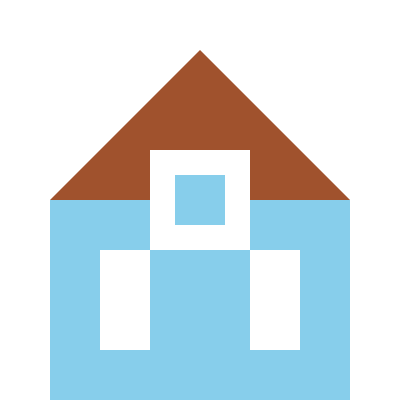Which famous Ontario landmark is represented by this abstract geometric composition? To identify the landmark, let's analyze the geometric shapes:

1. The overall structure is triangular, with a large triangle forming the main body.
2. There's a square shape in the center of the triangle, resembling a window or observation deck.
3. Two rectangular shapes at the bottom could represent legs or support structures.
4. The blue background suggests a sky, while the brown triangle implies a building.

These elements combined point to a iconic tower-like structure. In Ontario, the most famous landmark fitting this description is the CN Tower in Toronto. The CN Tower is characterized by:

- A distinctive triangular silhouette
- An observation deck near the top
- A narrow base with supporting structures
- Its prominence against the Toronto skyline

The abstract representation captures these key features of the CN Tower, albeit in a simplified, geometric form.
Answer: CN Tower 